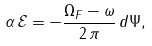Convert formula to latex. <formula><loc_0><loc_0><loc_500><loc_500>\alpha \, \mathcal { E } = - \frac { \Omega _ { F } - \omega } { 2 \, \pi } \, d \Psi ,</formula> 